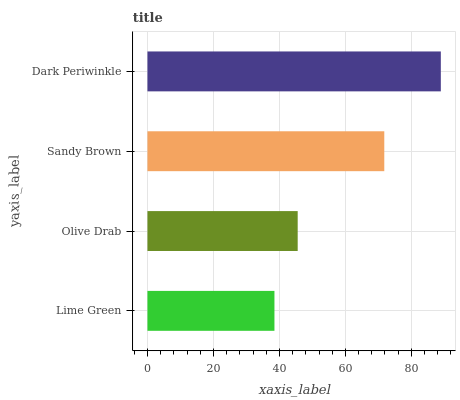Is Lime Green the minimum?
Answer yes or no. Yes. Is Dark Periwinkle the maximum?
Answer yes or no. Yes. Is Olive Drab the minimum?
Answer yes or no. No. Is Olive Drab the maximum?
Answer yes or no. No. Is Olive Drab greater than Lime Green?
Answer yes or no. Yes. Is Lime Green less than Olive Drab?
Answer yes or no. Yes. Is Lime Green greater than Olive Drab?
Answer yes or no. No. Is Olive Drab less than Lime Green?
Answer yes or no. No. Is Sandy Brown the high median?
Answer yes or no. Yes. Is Olive Drab the low median?
Answer yes or no. Yes. Is Lime Green the high median?
Answer yes or no. No. Is Sandy Brown the low median?
Answer yes or no. No. 